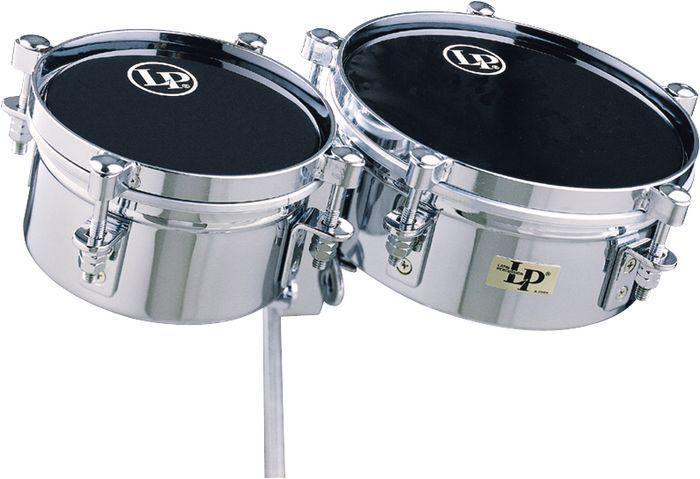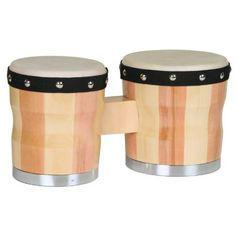The first image is the image on the left, the second image is the image on the right. Assess this claim about the two images: "There are two sets of bongo drums.". Correct or not? Answer yes or no. No. The first image is the image on the left, the second image is the image on the right. Analyze the images presented: Is the assertion "Each image contains one connected, side-by-side pair of drums with short feet on each drum, and one of the drum pairs is brown with multiple parallel lines encircling it." valid? Answer yes or no. No. 